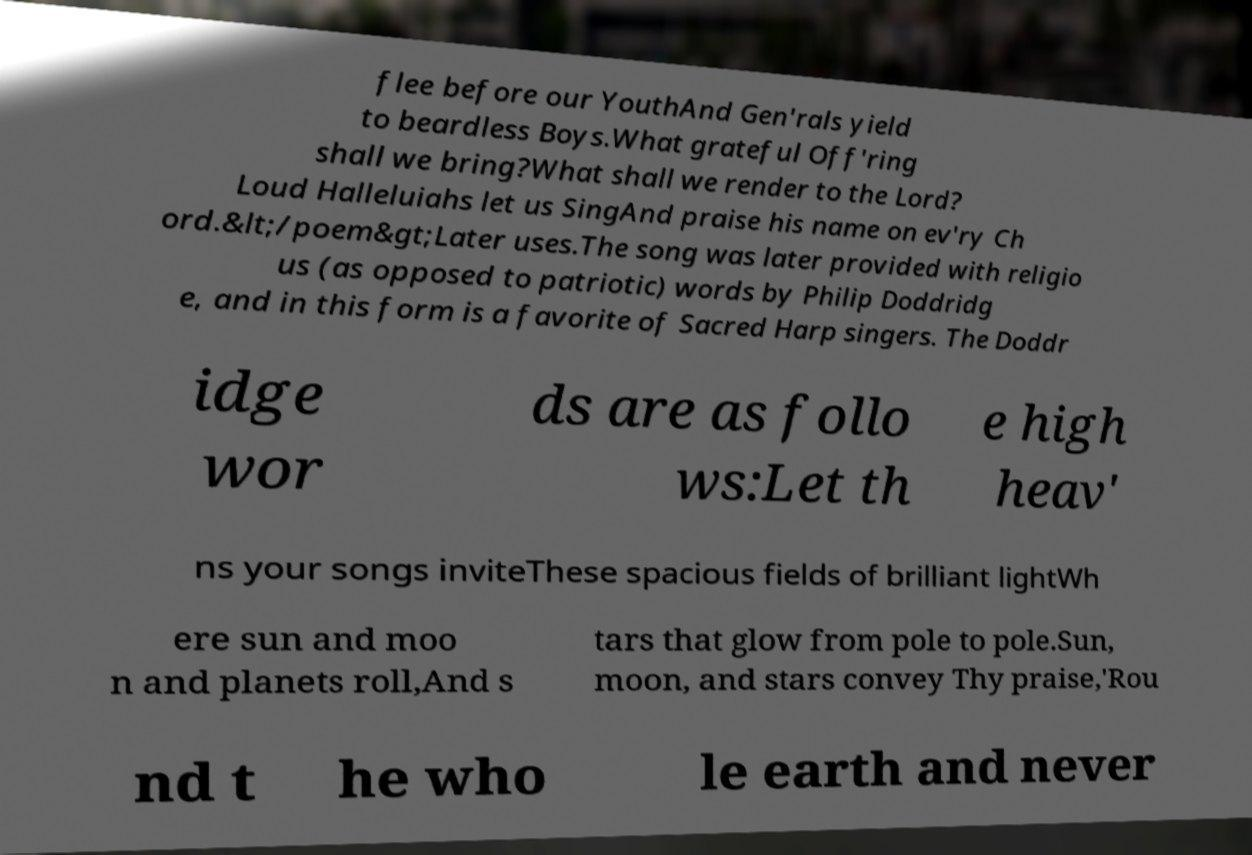I need the written content from this picture converted into text. Can you do that? flee before our YouthAnd Gen'rals yield to beardless Boys.What grateful Off'ring shall we bring?What shall we render to the Lord? Loud Halleluiahs let us SingAnd praise his name on ev'ry Ch ord.&lt;/poem&gt;Later uses.The song was later provided with religio us (as opposed to patriotic) words by Philip Doddridg e, and in this form is a favorite of Sacred Harp singers. The Doddr idge wor ds are as follo ws:Let th e high heav' ns your songs inviteThese spacious fields of brilliant lightWh ere sun and moo n and planets roll,And s tars that glow from pole to pole.Sun, moon, and stars convey Thy praise,'Rou nd t he who le earth and never 